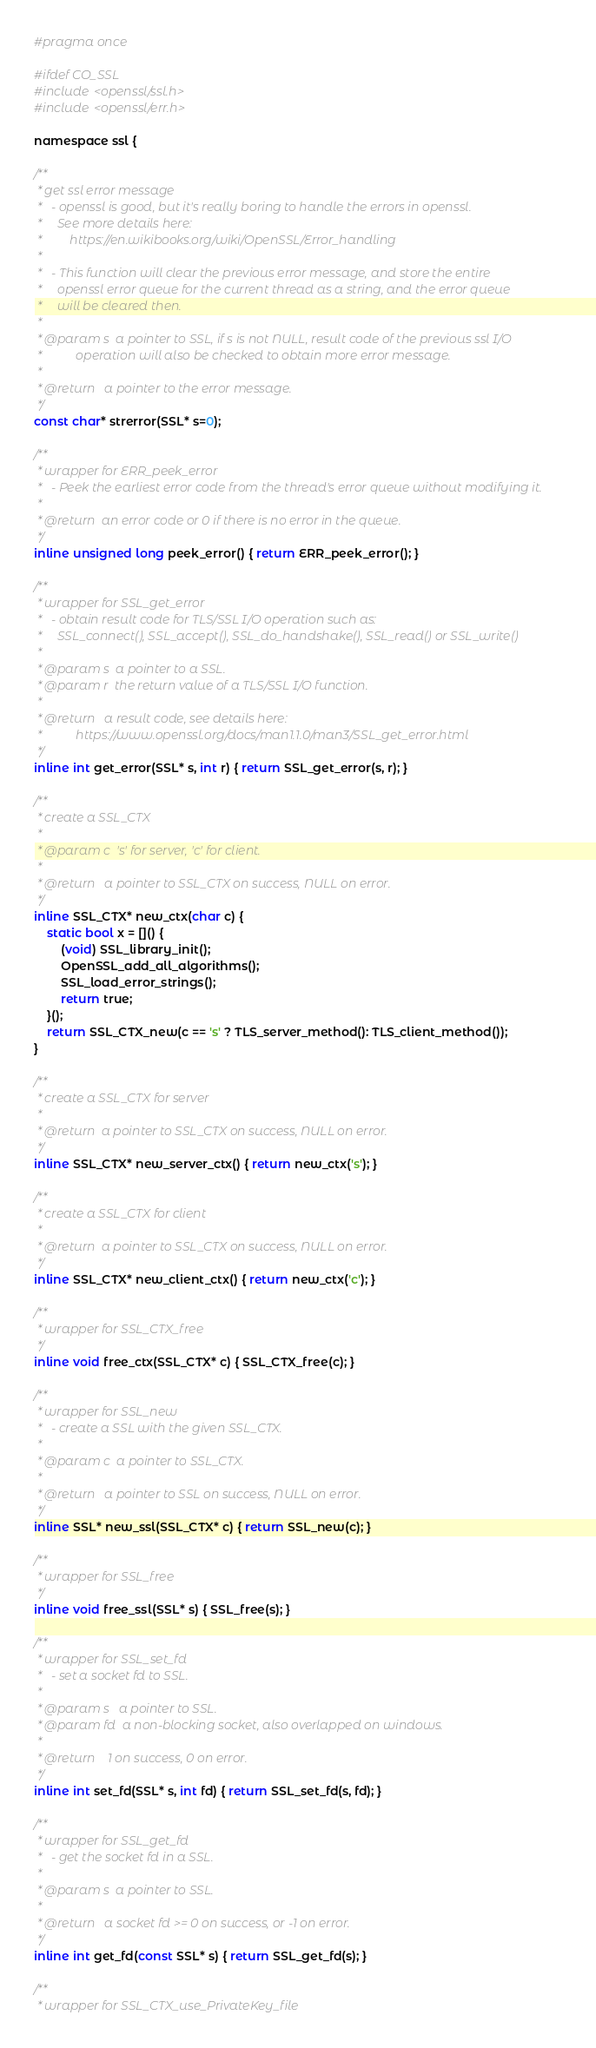<code> <loc_0><loc_0><loc_500><loc_500><_C_>#pragma once

#ifdef CO_SSL
#include <openssl/ssl.h>
#include <openssl/err.h>

namespace ssl {

/**
 * get ssl error message 
 *   - openssl is good, but it's really boring to handle the errors in openssl. 
 *     See more details here: 
 *         https://en.wikibooks.org/wiki/OpenSSL/Error_handling
 * 
 *   - This function will clear the previous error message, and store the entire 
 *     openssl error queue for the current thread as a string, and the error queue 
 *     will be cleared then. 
 * 
 * @param s  a pointer to SSL, if s is not NULL, result code of the previous ssl I/O 
 *           operation will also be checked to obtain more error message.
 * 
 * @return   a pointer to the error message.
 */
const char* strerror(SSL* s=0);

/**
 * wrapper for ERR_peek_error 
 *   - Peek the earliest error code from the thread's error queue without modifying it.
 * 
 * @return  an error code or 0 if there is no error in the queue.
 */
inline unsigned long peek_error() { return ERR_peek_error(); }

/**
 * wrapper for SSL_get_error 
 *   - obtain result code for TLS/SSL I/O operation such as: 
 *     SSL_connect(), SSL_accept(), SSL_do_handshake(), SSL_read() or SSL_write()
 * 
 * @param s  a pointer to a SSL.
 * @param r  the return value of a TLS/SSL I/O function.
 * 
 * @return   a result code, see details here:
 *           https://www.openssl.org/docs/man1.1.0/man3/SSL_get_error.html
 */
inline int get_error(SSL* s, int r) { return SSL_get_error(s, r); }

/**
 * create a SSL_CTX
 * 
 * @param c  's' for server, 'c' for client.
 * 
 * @return   a pointer to SSL_CTX on success, NULL on error.
 */
inline SSL_CTX* new_ctx(char c) {
    static bool x = []() {
        (void) SSL_library_init();
        OpenSSL_add_all_algorithms();
        SSL_load_error_strings();
        return true;
    }();
    return SSL_CTX_new(c == 's' ? TLS_server_method(): TLS_client_method());
}

/**
 * create a SSL_CTX for server
 * 
 * @return  a pointer to SSL_CTX on success, NULL on error.
 */
inline SSL_CTX* new_server_ctx() { return new_ctx('s'); }

/**
 * create a SSL_CTX for client
 * 
 * @return  a pointer to SSL_CTX on success, NULL on error.
 */
inline SSL_CTX* new_client_ctx() { return new_ctx('c'); }

/**
 * wrapper for SSL_CTX_free
 */
inline void free_ctx(SSL_CTX* c) { SSL_CTX_free(c); }

/**
 * wrapper for SSL_new
 *   - create a SSL with the given SSL_CTX. 
 * 
 * @param c  a pointer to SSL_CTX.
 * 
 * @return   a pointer to SSL on success, NULL on error.
 */
inline SSL* new_ssl(SSL_CTX* c) { return SSL_new(c); }

/**
 * wrapper for SSL_free 
 */
inline void free_ssl(SSL* s) { SSL_free(s); }

/**
 * wrapper for SSL_set_fd 
 *   - set a socket fd to SSL. 
 * 
 * @param s   a pointer to SSL.
 * @param fd  a non-blocking socket, also overlapped on windows.
 * 
 * @return    1 on success, 0 on error.
 */
inline int set_fd(SSL* s, int fd) { return SSL_set_fd(s, fd); }

/**
 * wrapper for SSL_get_fd 
 *   - get the socket fd in a SSL. 
 * 
 * @param s  a pointer to SSL.
 * 
 * @return   a socket fd >= 0 on success, or -1 on error.
 */
inline int get_fd(const SSL* s) { return SSL_get_fd(s); }

/**
 * wrapper for SSL_CTX_use_PrivateKey_file </code> 